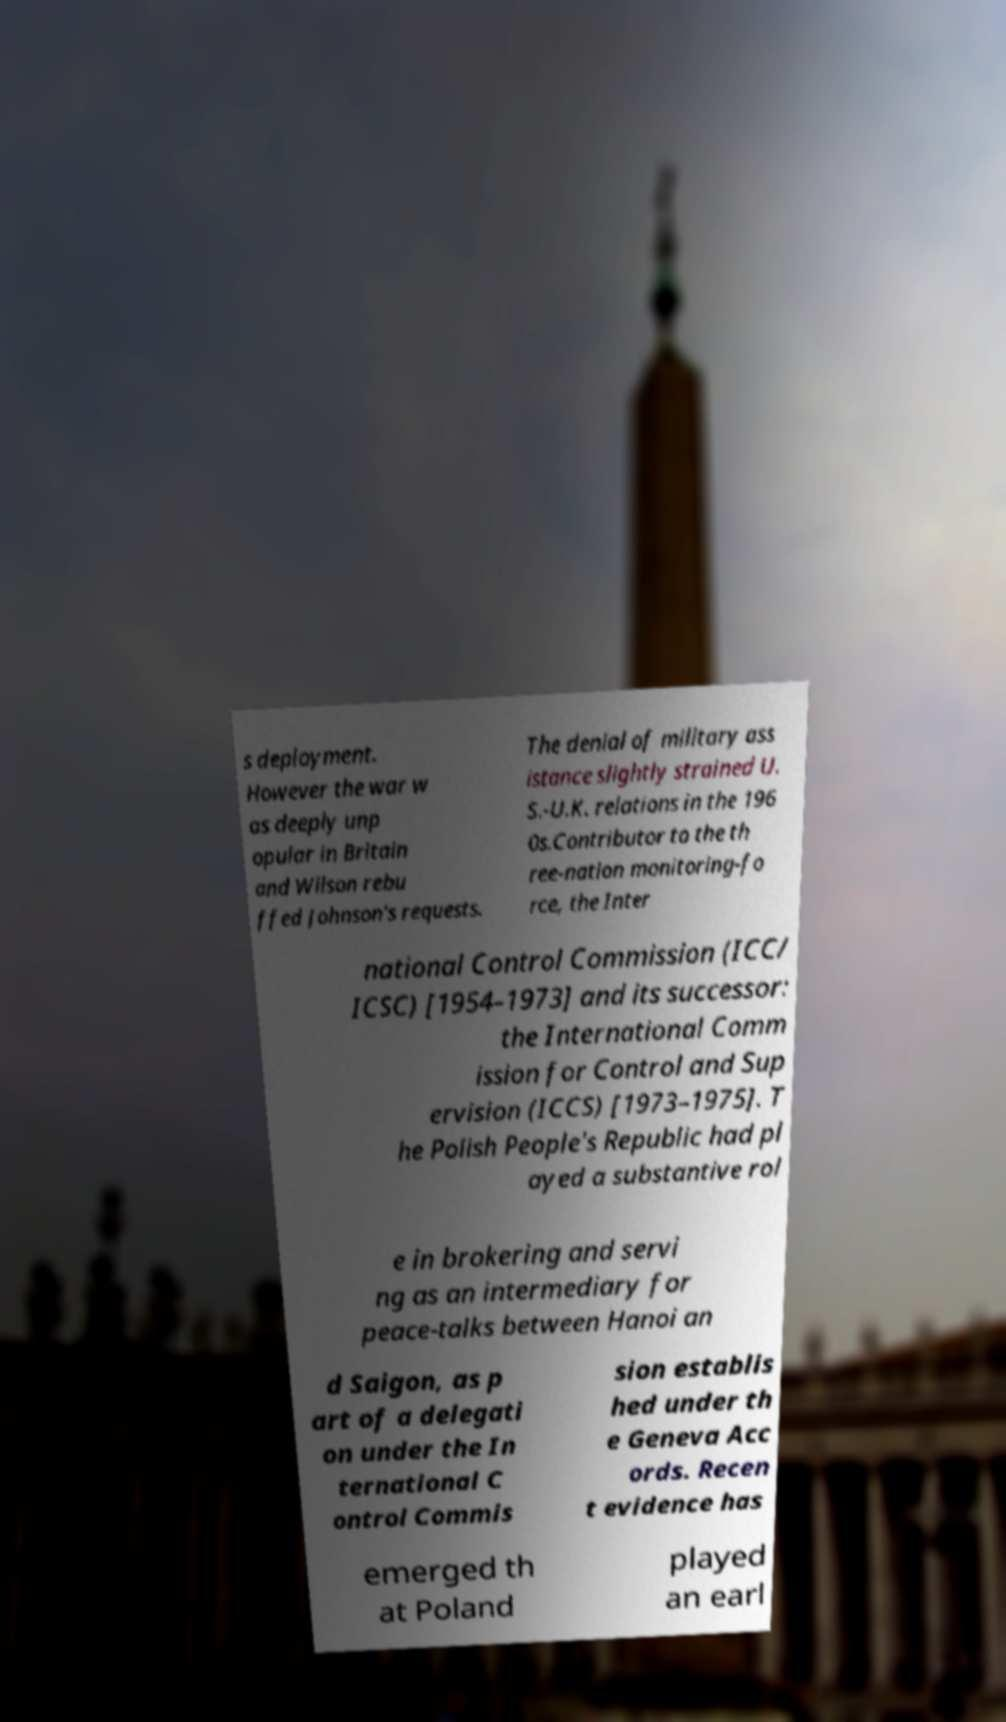Please identify and transcribe the text found in this image. s deployment. However the war w as deeply unp opular in Britain and Wilson rebu ffed Johnson's requests. The denial of military ass istance slightly strained U. S.-U.K. relations in the 196 0s.Contributor to the th ree-nation monitoring-fo rce, the Inter national Control Commission (ICC/ ICSC) [1954–1973] and its successor: the International Comm ission for Control and Sup ervision (ICCS) [1973–1975]. T he Polish People's Republic had pl ayed a substantive rol e in brokering and servi ng as an intermediary for peace-talks between Hanoi an d Saigon, as p art of a delegati on under the In ternational C ontrol Commis sion establis hed under th e Geneva Acc ords. Recen t evidence has emerged th at Poland played an earl 